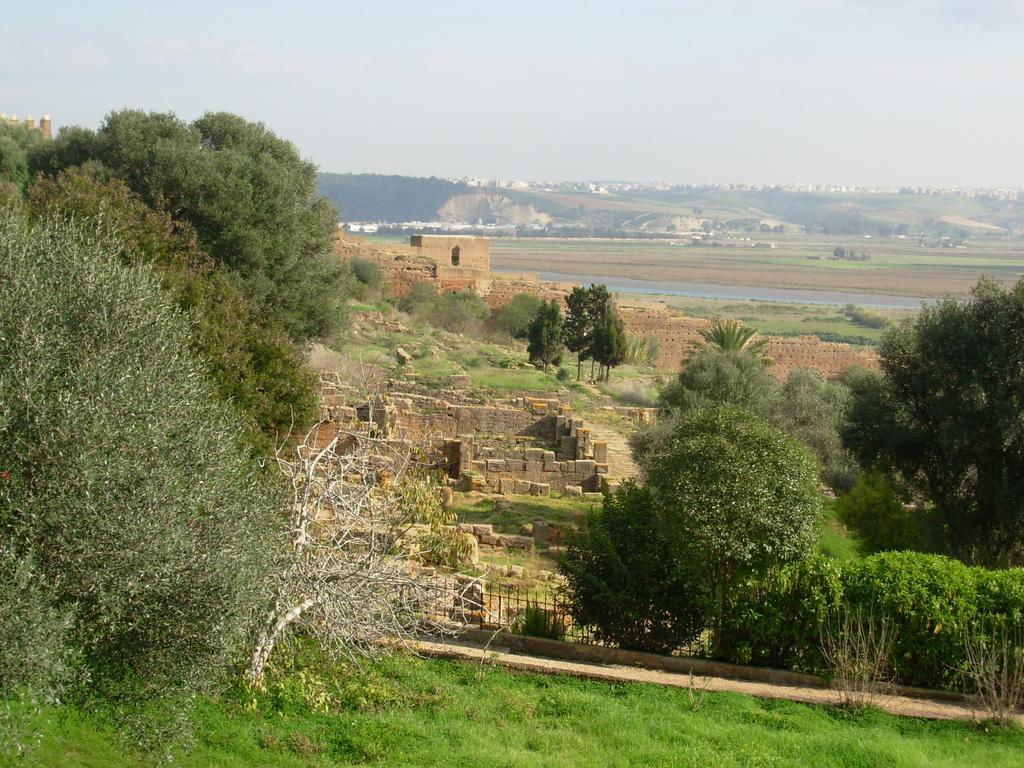Please provide a concise description of this image. In the image there are many trees and grass surface and there are some constructions in between those trees, in the background there are mountains. 